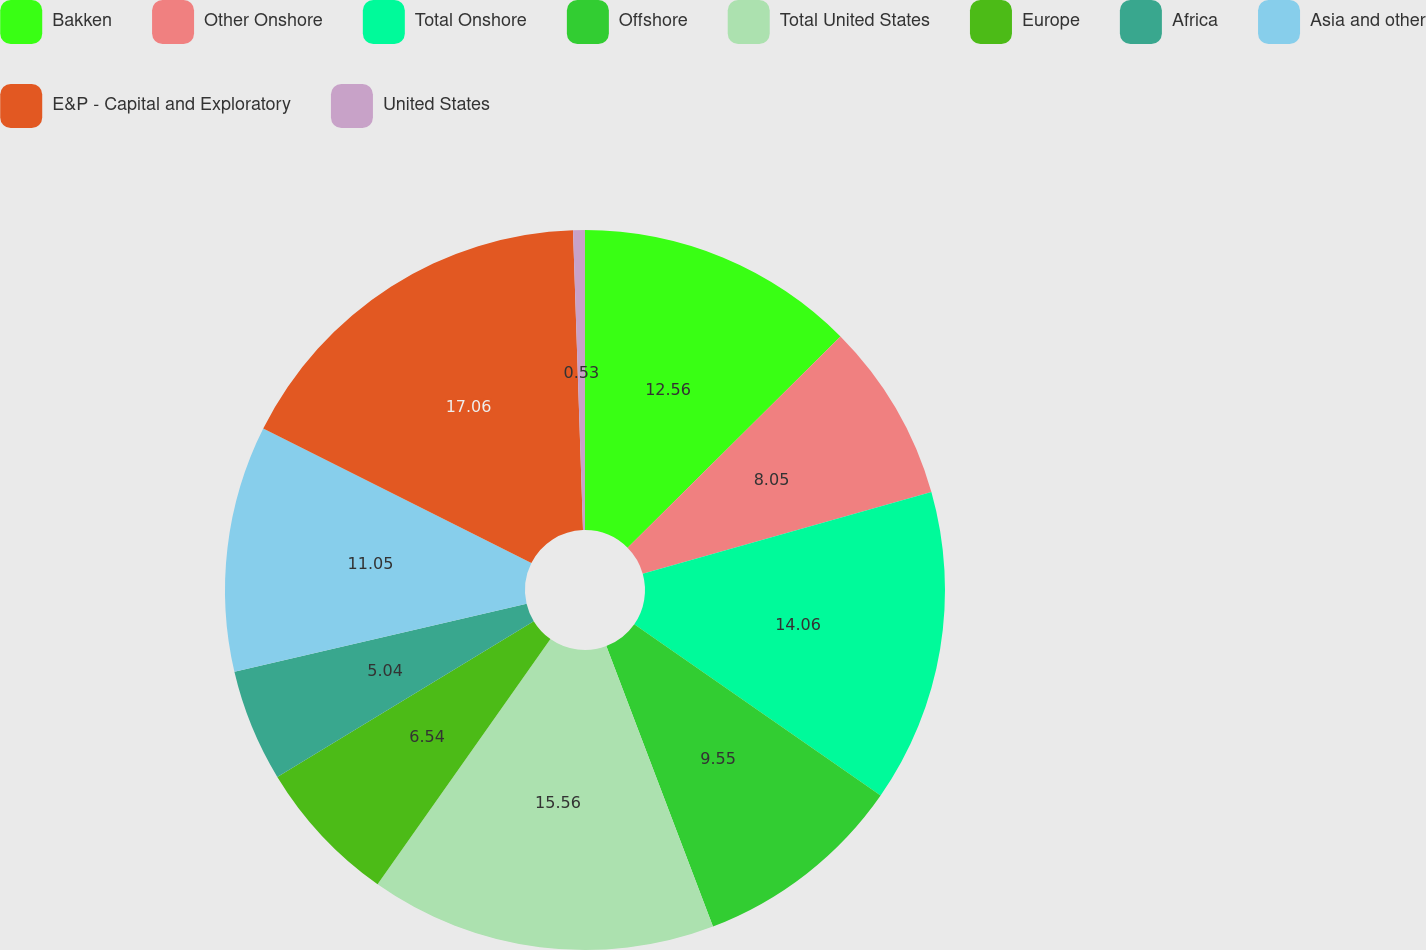<chart> <loc_0><loc_0><loc_500><loc_500><pie_chart><fcel>Bakken<fcel>Other Onshore<fcel>Total Onshore<fcel>Offshore<fcel>Total United States<fcel>Europe<fcel>Africa<fcel>Asia and other<fcel>E&P - Capital and Exploratory<fcel>United States<nl><fcel>12.56%<fcel>8.05%<fcel>14.06%<fcel>9.55%<fcel>15.56%<fcel>6.54%<fcel>5.04%<fcel>11.05%<fcel>17.07%<fcel>0.53%<nl></chart> 